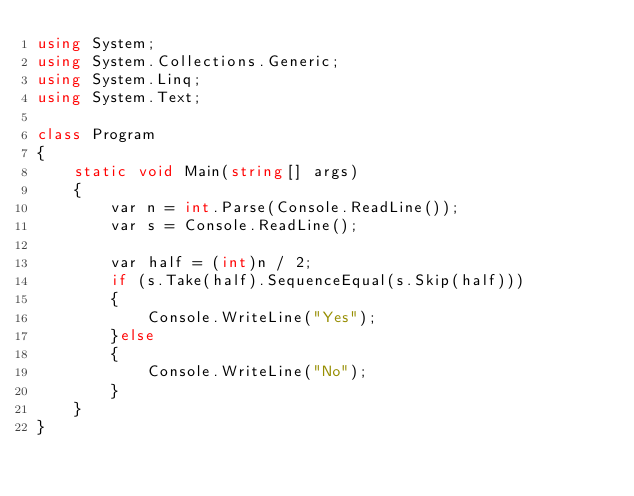Convert code to text. <code><loc_0><loc_0><loc_500><loc_500><_C#_>using System;
using System.Collections.Generic;
using System.Linq;
using System.Text;

class Program
{
    static void Main(string[] args)
    {
        var n = int.Parse(Console.ReadLine());
        var s = Console.ReadLine();

        var half = (int)n / 2;
        if (s.Take(half).SequenceEqual(s.Skip(half)))
        {
            Console.WriteLine("Yes");
        }else
        {
            Console.WriteLine("No");
        }
    }
}</code> 